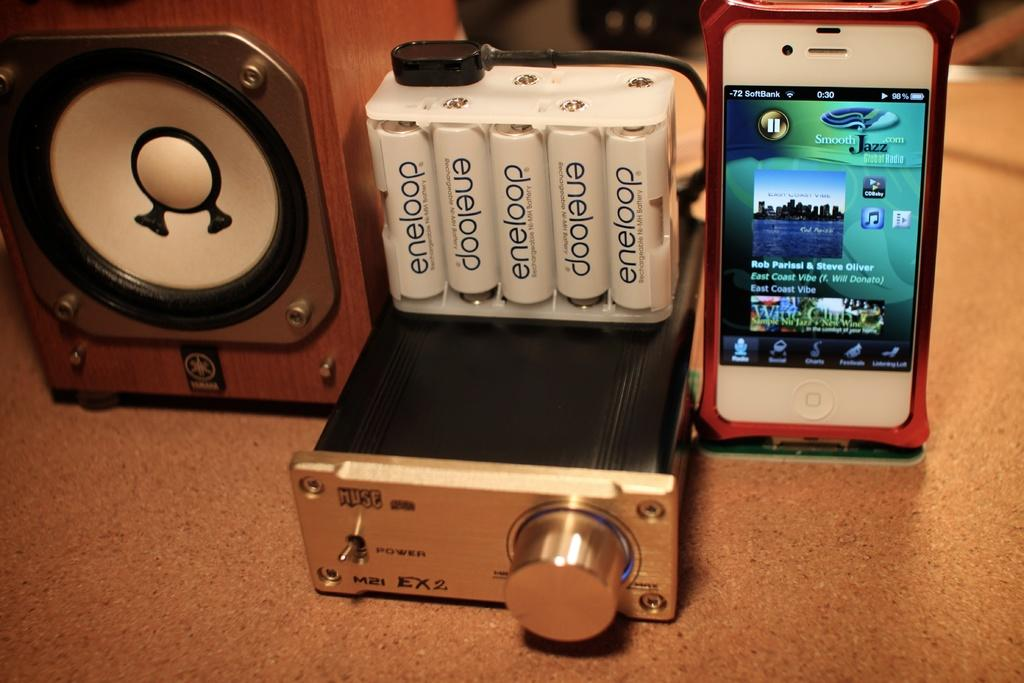<image>
Summarize the visual content of the image. A  white iphone hooked up to a device and a case of Eneloop brand batteries in a clear case beside 